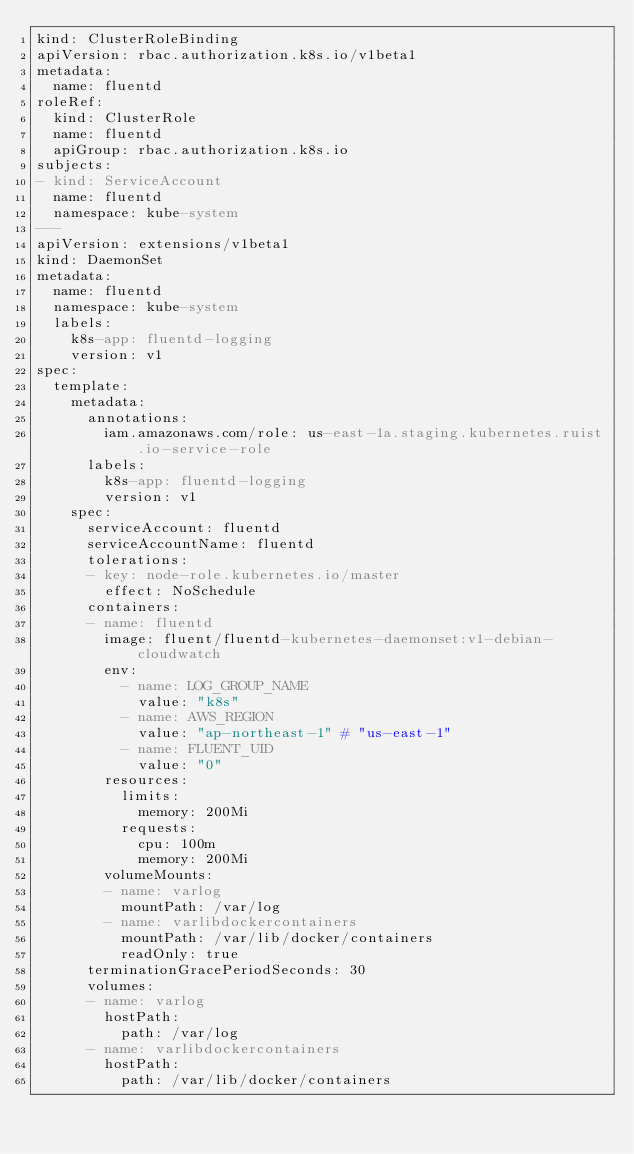<code> <loc_0><loc_0><loc_500><loc_500><_YAML_>kind: ClusterRoleBinding
apiVersion: rbac.authorization.k8s.io/v1beta1
metadata:
  name: fluentd
roleRef:
  kind: ClusterRole
  name: fluentd
  apiGroup: rbac.authorization.k8s.io
subjects:
- kind: ServiceAccount
  name: fluentd
  namespace: kube-system
---
apiVersion: extensions/v1beta1
kind: DaemonSet
metadata:
  name: fluentd
  namespace: kube-system
  labels:
    k8s-app: fluentd-logging
    version: v1
spec:
  template:
    metadata:
      annotations:
        iam.amazonaws.com/role: us-east-1a.staging.kubernetes.ruist.io-service-role
      labels:
        k8s-app: fluentd-logging
        version: v1
    spec:
      serviceAccount: fluentd
      serviceAccountName: fluentd
      tolerations:
      - key: node-role.kubernetes.io/master
        effect: NoSchedule
      containers:
      - name: fluentd
        image: fluent/fluentd-kubernetes-daemonset:v1-debian-cloudwatch
        env:
          - name: LOG_GROUP_NAME
            value: "k8s"
          - name: AWS_REGION
            value: "ap-northeast-1" # "us-east-1"
          - name: FLUENT_UID
            value: "0"
        resources:
          limits:
            memory: 200Mi
          requests:
            cpu: 100m
            memory: 200Mi
        volumeMounts:
        - name: varlog
          mountPath: /var/log
        - name: varlibdockercontainers
          mountPath: /var/lib/docker/containers
          readOnly: true
      terminationGracePeriodSeconds: 30
      volumes:
      - name: varlog
        hostPath:
          path: /var/log
      - name: varlibdockercontainers
        hostPath:
          path: /var/lib/docker/containers
</code> 